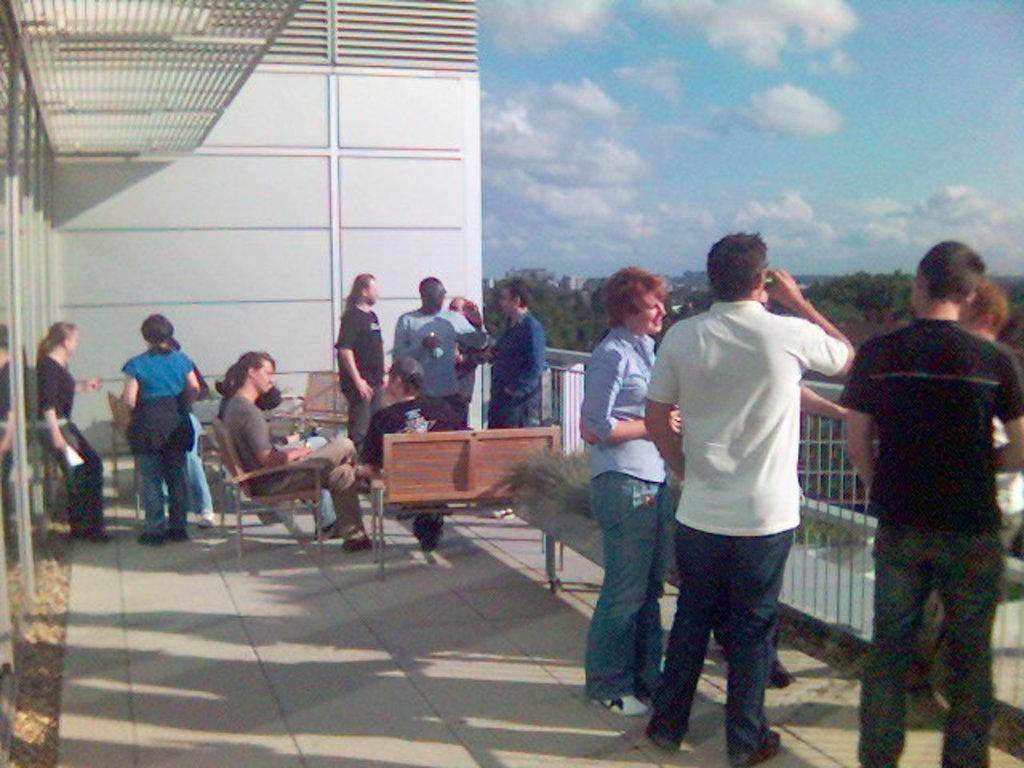What are the people in the image doing? There are people standing and sitting on benches in the image. What type of vegetation is on the right side of the image? There are trees on the right side of the image. What is visible at the top of the image? The sky is visible at the top of the image. How many ants can be seen crawling on the people in the image? There are no ants visible in the image; it only shows people standing and sitting on benches. What type of fowl is perched on the trees in the image? There are no fowl present in the image; it only features trees on the right side. 